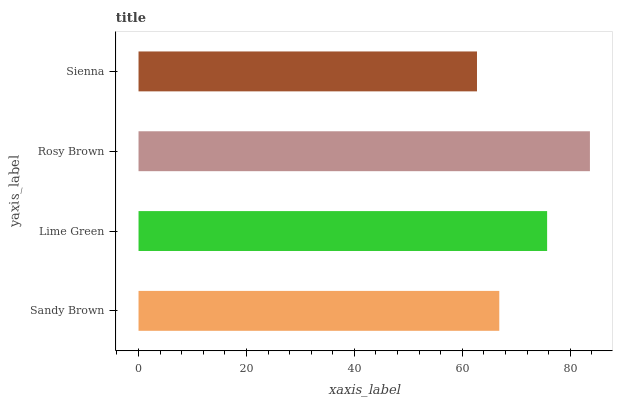Is Sienna the minimum?
Answer yes or no. Yes. Is Rosy Brown the maximum?
Answer yes or no. Yes. Is Lime Green the minimum?
Answer yes or no. No. Is Lime Green the maximum?
Answer yes or no. No. Is Lime Green greater than Sandy Brown?
Answer yes or no. Yes. Is Sandy Brown less than Lime Green?
Answer yes or no. Yes. Is Sandy Brown greater than Lime Green?
Answer yes or no. No. Is Lime Green less than Sandy Brown?
Answer yes or no. No. Is Lime Green the high median?
Answer yes or no. Yes. Is Sandy Brown the low median?
Answer yes or no. Yes. Is Sandy Brown the high median?
Answer yes or no. No. Is Lime Green the low median?
Answer yes or no. No. 